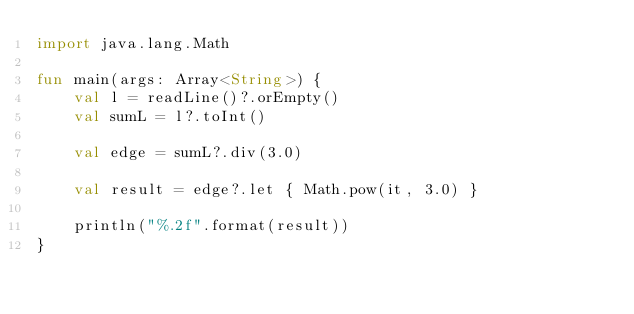Convert code to text. <code><loc_0><loc_0><loc_500><loc_500><_Kotlin_>import java.lang.Math

fun main(args: Array<String>) {
    val l = readLine()?.orEmpty()
    val sumL = l?.toInt()

    val edge = sumL?.div(3.0)

    val result = edge?.let { Math.pow(it, 3.0) }

    println("%.2f".format(result))
}</code> 